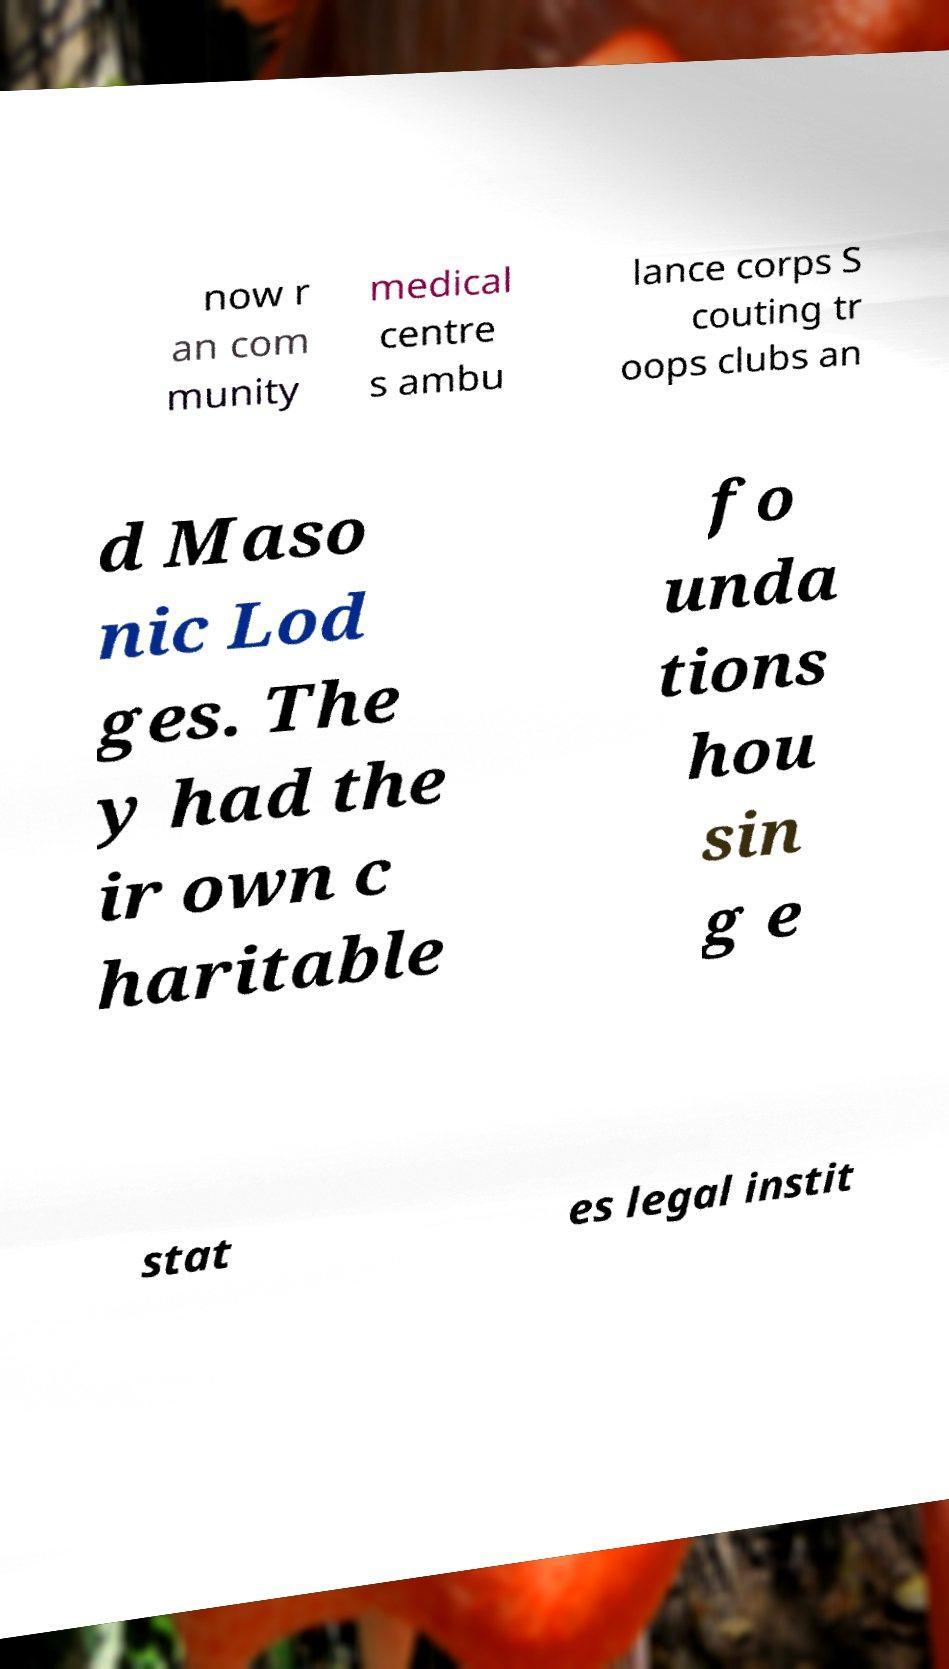Can you read and provide the text displayed in the image?This photo seems to have some interesting text. Can you extract and type it out for me? now r an com munity medical centre s ambu lance corps S couting tr oops clubs an d Maso nic Lod ges. The y had the ir own c haritable fo unda tions hou sin g e stat es legal instit 